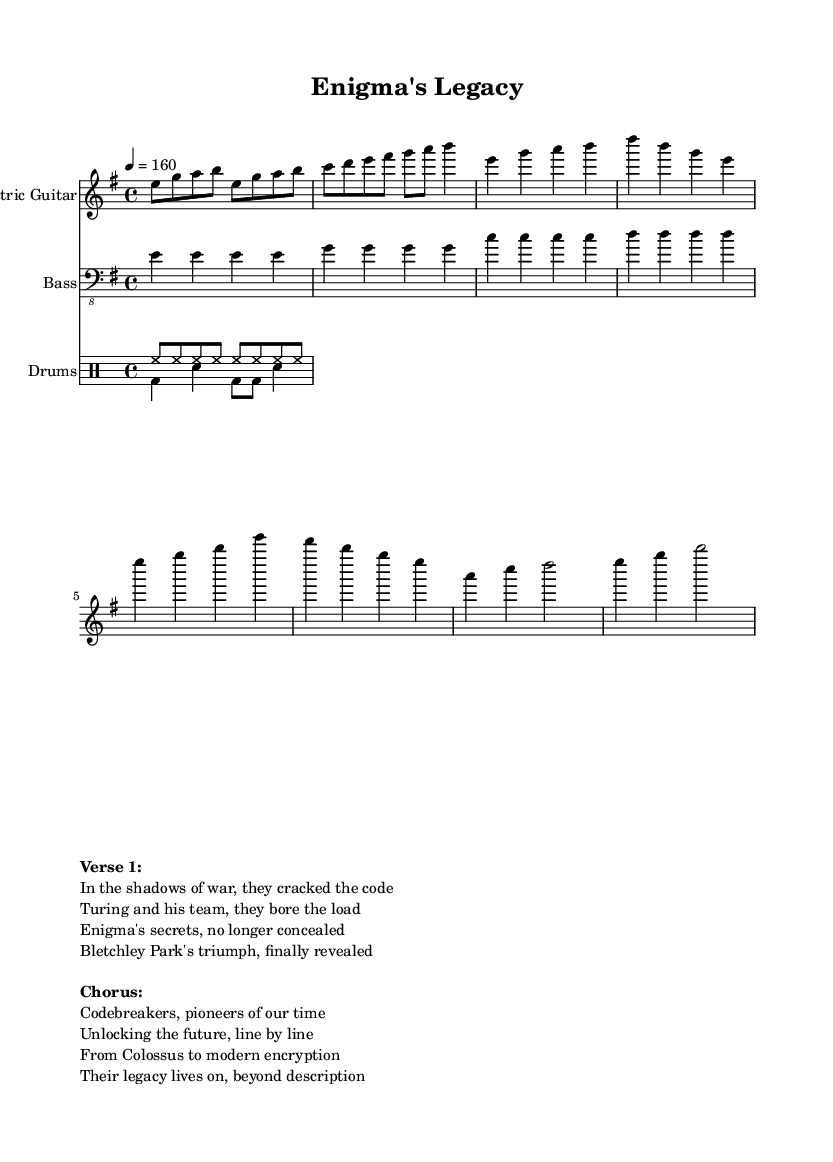What is the key signature of this music? The key signature indicated in the music is E minor, which is shown at the beginning of the global section.
Answer: E minor What is the time signature of this music? The time signature appears at the beginning as well and is noted as 4/4, indicating four beats per measure.
Answer: 4/4 What is the tempo marking for this piece? The tempo marking specified in the global section is quarter note equals 160, indicating the speed of the music.
Answer: 160 How many measures are in the intro section for guitar? The intro section for guitar has two measures, as indicated by the first line of notes before the verse begins.
Answer: 2 What instrument primarily plays the rhythm in this score? The bass guitar primarily plays the rhythm, as denoted in the rhythms section and notated in bass clef.
Answer: Bass What theme does the chorus address in the lyrics? The theme of the chorus celebrates the achievements of codebreakers and their legacy in advancing technology, as expressed in the lyrics.
Answer: Codebreakers' legacy In what context is "Bletchley Park" mentioned? "Bletchley Park" is mentioned in the verse as a significant site for the achievements of the codebreakers during World War II, where their work was carried out.
Answer: Significant site 